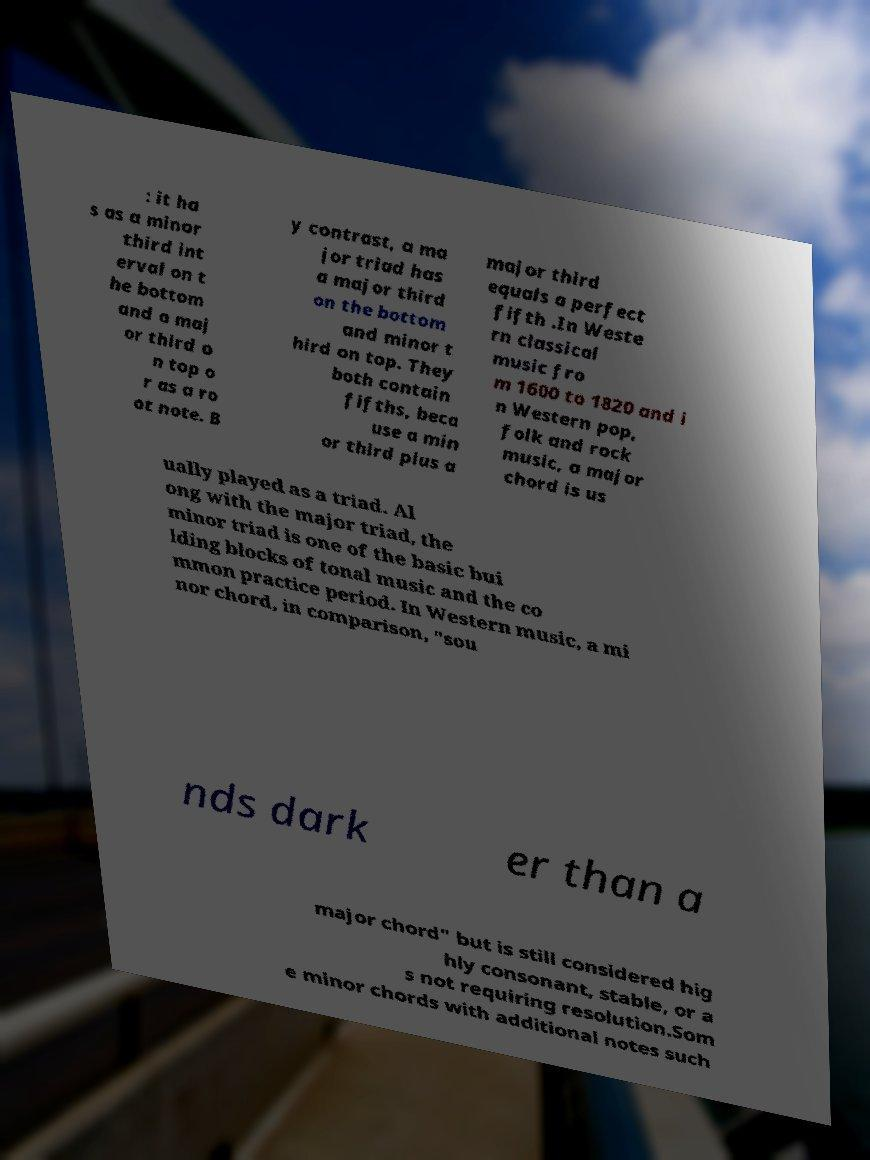For documentation purposes, I need the text within this image transcribed. Could you provide that? : it ha s as a minor third int erval on t he bottom and a maj or third o n top o r as a ro ot note. B y contrast, a ma jor triad has a major third on the bottom and minor t hird on top. They both contain fifths, beca use a min or third plus a major third equals a perfect fifth .In Weste rn classical music fro m 1600 to 1820 and i n Western pop, folk and rock music, a major chord is us ually played as a triad. Al ong with the major triad, the minor triad is one of the basic bui lding blocks of tonal music and the co mmon practice period. In Western music, a mi nor chord, in comparison, "sou nds dark er than a major chord" but is still considered hig hly consonant, stable, or a s not requiring resolution.Som e minor chords with additional notes such 